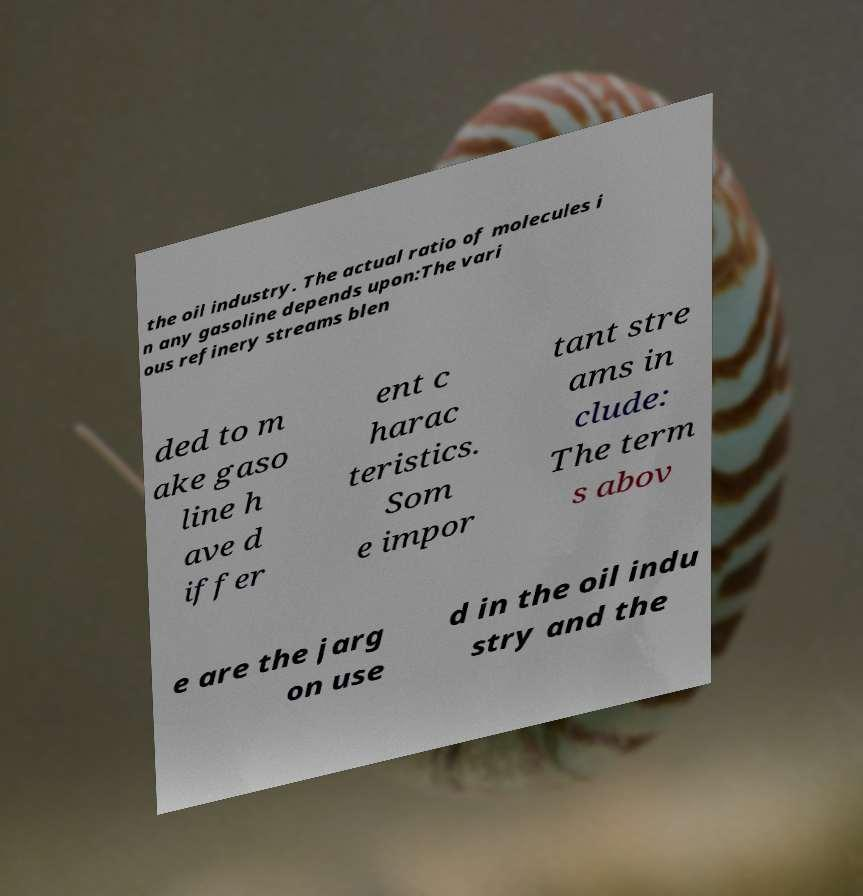There's text embedded in this image that I need extracted. Can you transcribe it verbatim? the oil industry. The actual ratio of molecules i n any gasoline depends upon:The vari ous refinery streams blen ded to m ake gaso line h ave d iffer ent c harac teristics. Som e impor tant stre ams in clude: The term s abov e are the jarg on use d in the oil indu stry and the 